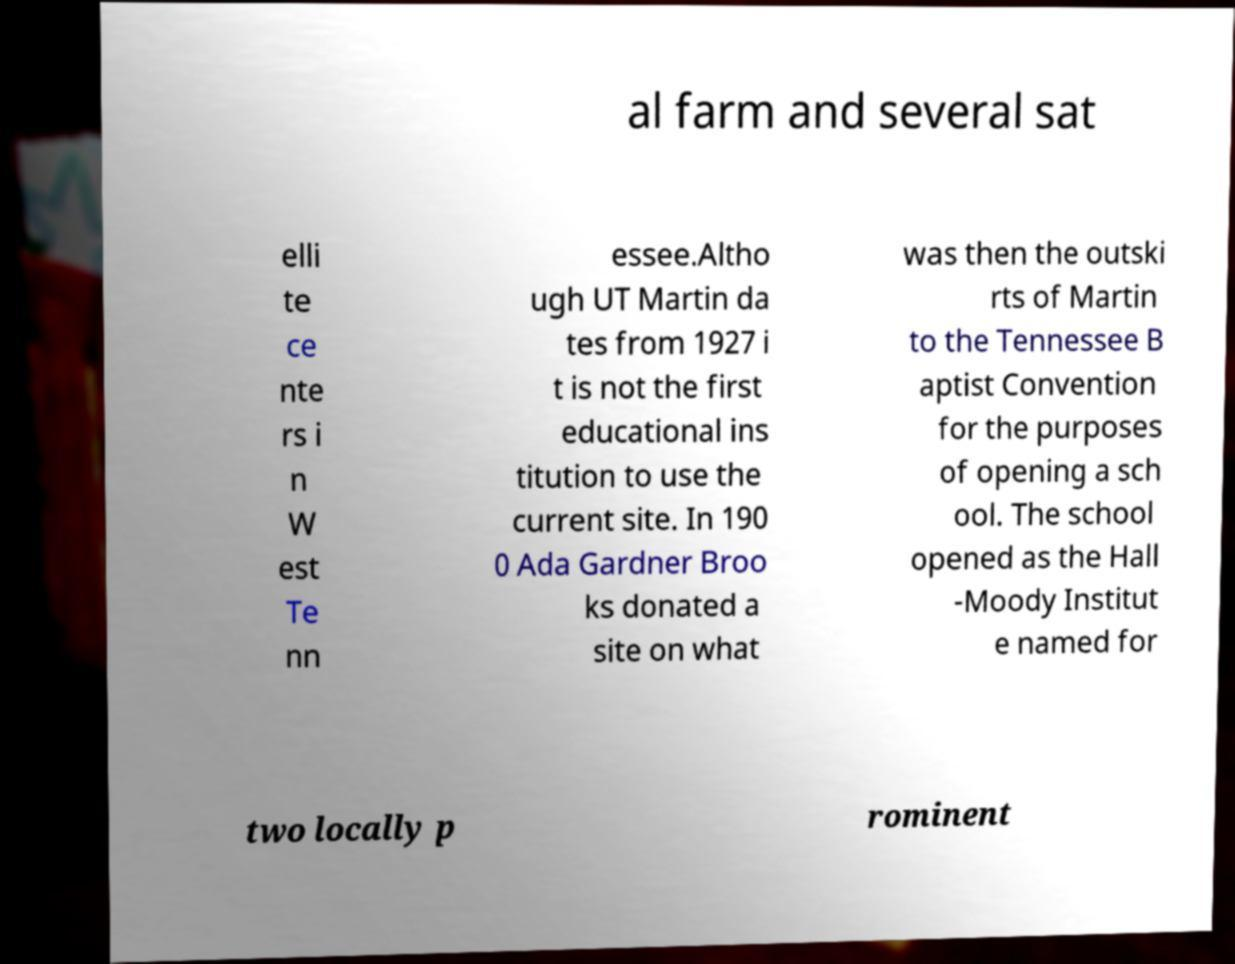Please read and relay the text visible in this image. What does it say? al farm and several sat elli te ce nte rs i n W est Te nn essee.Altho ugh UT Martin da tes from 1927 i t is not the first educational ins titution to use the current site. In 190 0 Ada Gardner Broo ks donated a site on what was then the outski rts of Martin to the Tennessee B aptist Convention for the purposes of opening a sch ool. The school opened as the Hall -Moody Institut e named for two locally p rominent 